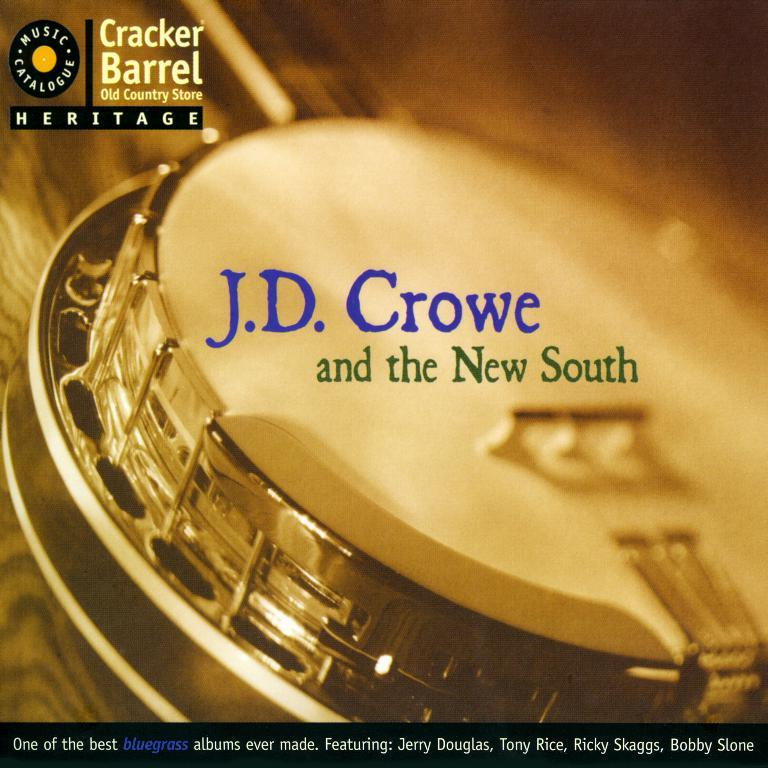Provide a one-sentence caption for the provided image. A banjo is on the cover of an album titled J.D. Crowe and the new south. 